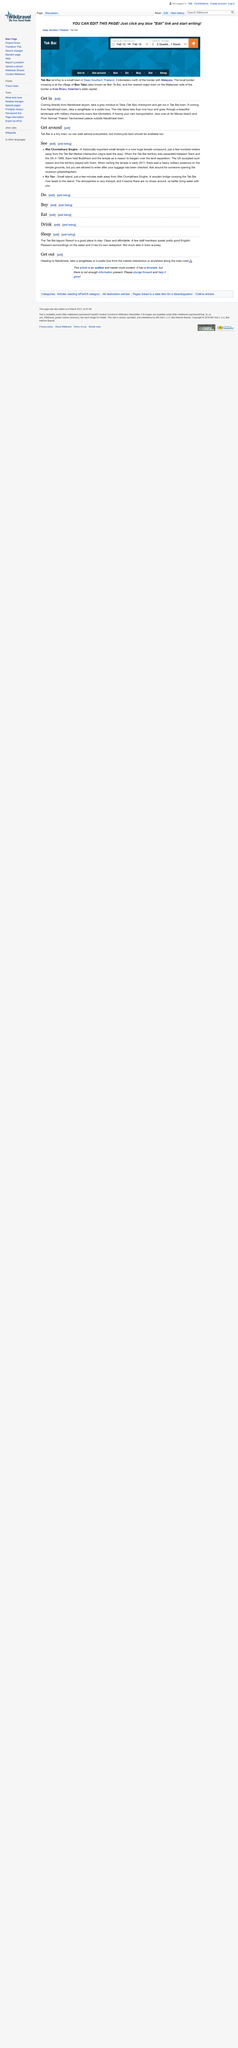Give some essential details in this illustration. Yes, walking is a viable option for getting around Tak Bai. Yes, both Are Ko Yao and Wat Choniathara Singhe are places that are worth seeing. On Ko Yao, the atmosphere is known for its tranquility. 